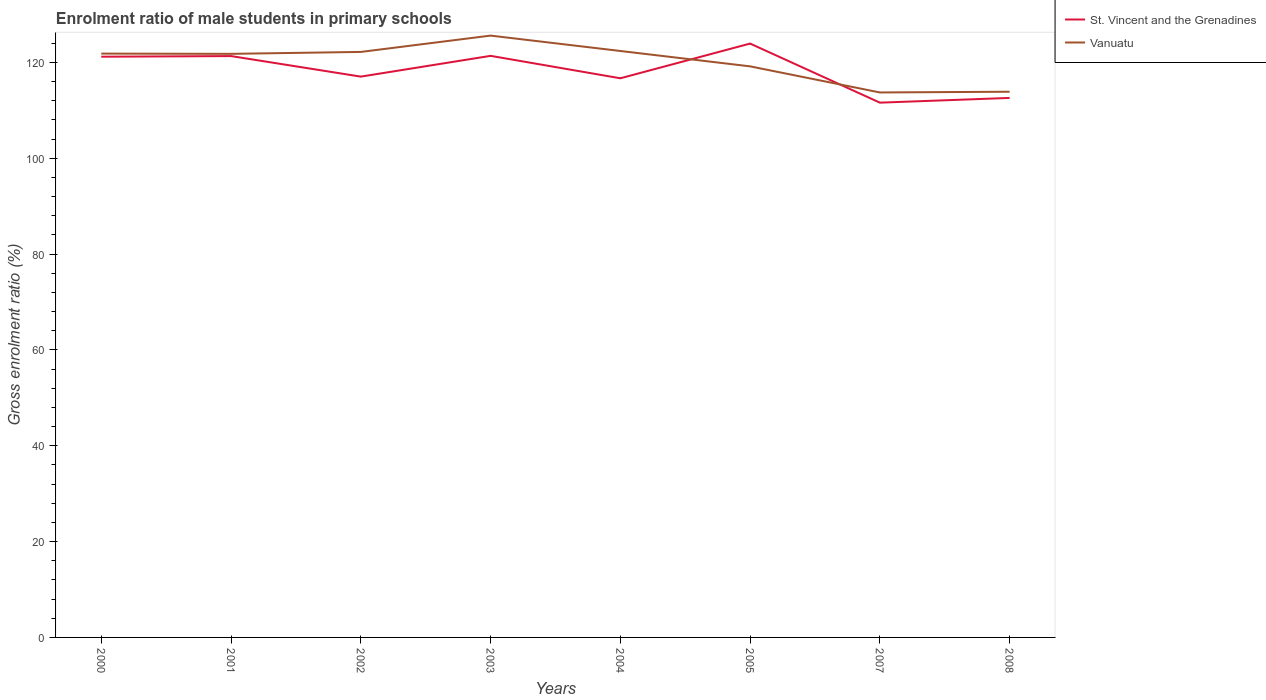Does the line corresponding to Vanuatu intersect with the line corresponding to St. Vincent and the Grenadines?
Your response must be concise. Yes. Across all years, what is the maximum enrolment ratio of male students in primary schools in St. Vincent and the Grenadines?
Keep it short and to the point. 111.59. In which year was the enrolment ratio of male students in primary schools in St. Vincent and the Grenadines maximum?
Make the answer very short. 2007. What is the total enrolment ratio of male students in primary schools in Vanuatu in the graph?
Provide a succinct answer. -0.55. What is the difference between the highest and the second highest enrolment ratio of male students in primary schools in St. Vincent and the Grenadines?
Your answer should be very brief. 12.33. How many years are there in the graph?
Offer a very short reply. 8. Are the values on the major ticks of Y-axis written in scientific E-notation?
Offer a terse response. No. How are the legend labels stacked?
Make the answer very short. Vertical. What is the title of the graph?
Your answer should be compact. Enrolment ratio of male students in primary schools. What is the label or title of the Y-axis?
Your response must be concise. Gross enrolment ratio (%). What is the Gross enrolment ratio (%) of St. Vincent and the Grenadines in 2000?
Make the answer very short. 121.18. What is the Gross enrolment ratio (%) in Vanuatu in 2000?
Your answer should be compact. 121.83. What is the Gross enrolment ratio (%) of St. Vincent and the Grenadines in 2001?
Offer a terse response. 121.31. What is the Gross enrolment ratio (%) in Vanuatu in 2001?
Ensure brevity in your answer.  121.77. What is the Gross enrolment ratio (%) in St. Vincent and the Grenadines in 2002?
Make the answer very short. 117.02. What is the Gross enrolment ratio (%) in Vanuatu in 2002?
Offer a very short reply. 122.17. What is the Gross enrolment ratio (%) of St. Vincent and the Grenadines in 2003?
Keep it short and to the point. 121.36. What is the Gross enrolment ratio (%) of Vanuatu in 2003?
Ensure brevity in your answer.  125.58. What is the Gross enrolment ratio (%) of St. Vincent and the Grenadines in 2004?
Give a very brief answer. 116.68. What is the Gross enrolment ratio (%) of Vanuatu in 2004?
Make the answer very short. 122.37. What is the Gross enrolment ratio (%) of St. Vincent and the Grenadines in 2005?
Offer a terse response. 123.92. What is the Gross enrolment ratio (%) in Vanuatu in 2005?
Your answer should be very brief. 119.16. What is the Gross enrolment ratio (%) of St. Vincent and the Grenadines in 2007?
Give a very brief answer. 111.59. What is the Gross enrolment ratio (%) in Vanuatu in 2007?
Provide a succinct answer. 113.72. What is the Gross enrolment ratio (%) in St. Vincent and the Grenadines in 2008?
Offer a very short reply. 112.58. What is the Gross enrolment ratio (%) in Vanuatu in 2008?
Your answer should be very brief. 113.87. Across all years, what is the maximum Gross enrolment ratio (%) of St. Vincent and the Grenadines?
Make the answer very short. 123.92. Across all years, what is the maximum Gross enrolment ratio (%) in Vanuatu?
Ensure brevity in your answer.  125.58. Across all years, what is the minimum Gross enrolment ratio (%) in St. Vincent and the Grenadines?
Give a very brief answer. 111.59. Across all years, what is the minimum Gross enrolment ratio (%) in Vanuatu?
Offer a terse response. 113.72. What is the total Gross enrolment ratio (%) in St. Vincent and the Grenadines in the graph?
Your answer should be compact. 945.62. What is the total Gross enrolment ratio (%) in Vanuatu in the graph?
Your answer should be compact. 960.47. What is the difference between the Gross enrolment ratio (%) in St. Vincent and the Grenadines in 2000 and that in 2001?
Ensure brevity in your answer.  -0.13. What is the difference between the Gross enrolment ratio (%) of Vanuatu in 2000 and that in 2001?
Offer a terse response. 0.05. What is the difference between the Gross enrolment ratio (%) in St. Vincent and the Grenadines in 2000 and that in 2002?
Provide a short and direct response. 4.16. What is the difference between the Gross enrolment ratio (%) of Vanuatu in 2000 and that in 2002?
Your response must be concise. -0.35. What is the difference between the Gross enrolment ratio (%) of St. Vincent and the Grenadines in 2000 and that in 2003?
Your answer should be very brief. -0.18. What is the difference between the Gross enrolment ratio (%) of Vanuatu in 2000 and that in 2003?
Keep it short and to the point. -3.75. What is the difference between the Gross enrolment ratio (%) of St. Vincent and the Grenadines in 2000 and that in 2004?
Your answer should be very brief. 4.5. What is the difference between the Gross enrolment ratio (%) in Vanuatu in 2000 and that in 2004?
Your response must be concise. -0.55. What is the difference between the Gross enrolment ratio (%) in St. Vincent and the Grenadines in 2000 and that in 2005?
Provide a succinct answer. -2.74. What is the difference between the Gross enrolment ratio (%) of Vanuatu in 2000 and that in 2005?
Offer a very short reply. 2.66. What is the difference between the Gross enrolment ratio (%) of St. Vincent and the Grenadines in 2000 and that in 2007?
Keep it short and to the point. 9.59. What is the difference between the Gross enrolment ratio (%) in Vanuatu in 2000 and that in 2007?
Your answer should be very brief. 8.11. What is the difference between the Gross enrolment ratio (%) in St. Vincent and the Grenadines in 2000 and that in 2008?
Offer a very short reply. 8.6. What is the difference between the Gross enrolment ratio (%) of Vanuatu in 2000 and that in 2008?
Your response must be concise. 7.96. What is the difference between the Gross enrolment ratio (%) of St. Vincent and the Grenadines in 2001 and that in 2002?
Offer a terse response. 4.29. What is the difference between the Gross enrolment ratio (%) of Vanuatu in 2001 and that in 2002?
Offer a terse response. -0.4. What is the difference between the Gross enrolment ratio (%) of St. Vincent and the Grenadines in 2001 and that in 2003?
Offer a very short reply. -0.05. What is the difference between the Gross enrolment ratio (%) in Vanuatu in 2001 and that in 2003?
Make the answer very short. -3.81. What is the difference between the Gross enrolment ratio (%) in St. Vincent and the Grenadines in 2001 and that in 2004?
Offer a terse response. 4.63. What is the difference between the Gross enrolment ratio (%) of Vanuatu in 2001 and that in 2004?
Your response must be concise. -0.6. What is the difference between the Gross enrolment ratio (%) of St. Vincent and the Grenadines in 2001 and that in 2005?
Offer a very short reply. -2.61. What is the difference between the Gross enrolment ratio (%) in Vanuatu in 2001 and that in 2005?
Your response must be concise. 2.61. What is the difference between the Gross enrolment ratio (%) in St. Vincent and the Grenadines in 2001 and that in 2007?
Your answer should be compact. 9.72. What is the difference between the Gross enrolment ratio (%) of Vanuatu in 2001 and that in 2007?
Your answer should be compact. 8.06. What is the difference between the Gross enrolment ratio (%) of St. Vincent and the Grenadines in 2001 and that in 2008?
Offer a very short reply. 8.73. What is the difference between the Gross enrolment ratio (%) in Vanuatu in 2001 and that in 2008?
Offer a very short reply. 7.91. What is the difference between the Gross enrolment ratio (%) of St. Vincent and the Grenadines in 2002 and that in 2003?
Give a very brief answer. -4.33. What is the difference between the Gross enrolment ratio (%) in Vanuatu in 2002 and that in 2003?
Your answer should be very brief. -3.41. What is the difference between the Gross enrolment ratio (%) in St. Vincent and the Grenadines in 2002 and that in 2004?
Your answer should be compact. 0.35. What is the difference between the Gross enrolment ratio (%) in Vanuatu in 2002 and that in 2004?
Keep it short and to the point. -0.2. What is the difference between the Gross enrolment ratio (%) in St. Vincent and the Grenadines in 2002 and that in 2005?
Offer a very short reply. -6.9. What is the difference between the Gross enrolment ratio (%) in Vanuatu in 2002 and that in 2005?
Make the answer very short. 3.01. What is the difference between the Gross enrolment ratio (%) in St. Vincent and the Grenadines in 2002 and that in 2007?
Provide a short and direct response. 5.43. What is the difference between the Gross enrolment ratio (%) of Vanuatu in 2002 and that in 2007?
Offer a very short reply. 8.46. What is the difference between the Gross enrolment ratio (%) of St. Vincent and the Grenadines in 2002 and that in 2008?
Your answer should be very brief. 4.44. What is the difference between the Gross enrolment ratio (%) of Vanuatu in 2002 and that in 2008?
Make the answer very short. 8.31. What is the difference between the Gross enrolment ratio (%) in St. Vincent and the Grenadines in 2003 and that in 2004?
Make the answer very short. 4.68. What is the difference between the Gross enrolment ratio (%) in Vanuatu in 2003 and that in 2004?
Offer a terse response. 3.21. What is the difference between the Gross enrolment ratio (%) of St. Vincent and the Grenadines in 2003 and that in 2005?
Provide a succinct answer. -2.56. What is the difference between the Gross enrolment ratio (%) in Vanuatu in 2003 and that in 2005?
Ensure brevity in your answer.  6.42. What is the difference between the Gross enrolment ratio (%) of St. Vincent and the Grenadines in 2003 and that in 2007?
Your answer should be compact. 9.77. What is the difference between the Gross enrolment ratio (%) of Vanuatu in 2003 and that in 2007?
Make the answer very short. 11.86. What is the difference between the Gross enrolment ratio (%) of St. Vincent and the Grenadines in 2003 and that in 2008?
Your response must be concise. 8.78. What is the difference between the Gross enrolment ratio (%) in Vanuatu in 2003 and that in 2008?
Keep it short and to the point. 11.71. What is the difference between the Gross enrolment ratio (%) of St. Vincent and the Grenadines in 2004 and that in 2005?
Make the answer very short. -7.24. What is the difference between the Gross enrolment ratio (%) of Vanuatu in 2004 and that in 2005?
Ensure brevity in your answer.  3.21. What is the difference between the Gross enrolment ratio (%) of St. Vincent and the Grenadines in 2004 and that in 2007?
Provide a succinct answer. 5.09. What is the difference between the Gross enrolment ratio (%) of Vanuatu in 2004 and that in 2007?
Ensure brevity in your answer.  8.65. What is the difference between the Gross enrolment ratio (%) of St. Vincent and the Grenadines in 2004 and that in 2008?
Give a very brief answer. 4.1. What is the difference between the Gross enrolment ratio (%) in Vanuatu in 2004 and that in 2008?
Your response must be concise. 8.5. What is the difference between the Gross enrolment ratio (%) of St. Vincent and the Grenadines in 2005 and that in 2007?
Offer a terse response. 12.33. What is the difference between the Gross enrolment ratio (%) in Vanuatu in 2005 and that in 2007?
Make the answer very short. 5.45. What is the difference between the Gross enrolment ratio (%) of St. Vincent and the Grenadines in 2005 and that in 2008?
Make the answer very short. 11.34. What is the difference between the Gross enrolment ratio (%) in Vanuatu in 2005 and that in 2008?
Keep it short and to the point. 5.3. What is the difference between the Gross enrolment ratio (%) of St. Vincent and the Grenadines in 2007 and that in 2008?
Give a very brief answer. -0.99. What is the difference between the Gross enrolment ratio (%) in Vanuatu in 2007 and that in 2008?
Your answer should be compact. -0.15. What is the difference between the Gross enrolment ratio (%) in St. Vincent and the Grenadines in 2000 and the Gross enrolment ratio (%) in Vanuatu in 2001?
Your answer should be very brief. -0.6. What is the difference between the Gross enrolment ratio (%) in St. Vincent and the Grenadines in 2000 and the Gross enrolment ratio (%) in Vanuatu in 2002?
Your response must be concise. -1. What is the difference between the Gross enrolment ratio (%) in St. Vincent and the Grenadines in 2000 and the Gross enrolment ratio (%) in Vanuatu in 2003?
Your answer should be very brief. -4.4. What is the difference between the Gross enrolment ratio (%) of St. Vincent and the Grenadines in 2000 and the Gross enrolment ratio (%) of Vanuatu in 2004?
Give a very brief answer. -1.19. What is the difference between the Gross enrolment ratio (%) in St. Vincent and the Grenadines in 2000 and the Gross enrolment ratio (%) in Vanuatu in 2005?
Ensure brevity in your answer.  2.02. What is the difference between the Gross enrolment ratio (%) in St. Vincent and the Grenadines in 2000 and the Gross enrolment ratio (%) in Vanuatu in 2007?
Keep it short and to the point. 7.46. What is the difference between the Gross enrolment ratio (%) of St. Vincent and the Grenadines in 2000 and the Gross enrolment ratio (%) of Vanuatu in 2008?
Keep it short and to the point. 7.31. What is the difference between the Gross enrolment ratio (%) in St. Vincent and the Grenadines in 2001 and the Gross enrolment ratio (%) in Vanuatu in 2002?
Offer a very short reply. -0.87. What is the difference between the Gross enrolment ratio (%) of St. Vincent and the Grenadines in 2001 and the Gross enrolment ratio (%) of Vanuatu in 2003?
Your answer should be very brief. -4.27. What is the difference between the Gross enrolment ratio (%) of St. Vincent and the Grenadines in 2001 and the Gross enrolment ratio (%) of Vanuatu in 2004?
Keep it short and to the point. -1.06. What is the difference between the Gross enrolment ratio (%) of St. Vincent and the Grenadines in 2001 and the Gross enrolment ratio (%) of Vanuatu in 2005?
Offer a very short reply. 2.15. What is the difference between the Gross enrolment ratio (%) in St. Vincent and the Grenadines in 2001 and the Gross enrolment ratio (%) in Vanuatu in 2007?
Your response must be concise. 7.59. What is the difference between the Gross enrolment ratio (%) of St. Vincent and the Grenadines in 2001 and the Gross enrolment ratio (%) of Vanuatu in 2008?
Give a very brief answer. 7.44. What is the difference between the Gross enrolment ratio (%) in St. Vincent and the Grenadines in 2002 and the Gross enrolment ratio (%) in Vanuatu in 2003?
Your answer should be compact. -8.56. What is the difference between the Gross enrolment ratio (%) in St. Vincent and the Grenadines in 2002 and the Gross enrolment ratio (%) in Vanuatu in 2004?
Your response must be concise. -5.35. What is the difference between the Gross enrolment ratio (%) of St. Vincent and the Grenadines in 2002 and the Gross enrolment ratio (%) of Vanuatu in 2005?
Keep it short and to the point. -2.14. What is the difference between the Gross enrolment ratio (%) of St. Vincent and the Grenadines in 2002 and the Gross enrolment ratio (%) of Vanuatu in 2007?
Your answer should be very brief. 3.3. What is the difference between the Gross enrolment ratio (%) in St. Vincent and the Grenadines in 2002 and the Gross enrolment ratio (%) in Vanuatu in 2008?
Make the answer very short. 3.15. What is the difference between the Gross enrolment ratio (%) in St. Vincent and the Grenadines in 2003 and the Gross enrolment ratio (%) in Vanuatu in 2004?
Offer a very short reply. -1.02. What is the difference between the Gross enrolment ratio (%) in St. Vincent and the Grenadines in 2003 and the Gross enrolment ratio (%) in Vanuatu in 2005?
Make the answer very short. 2.19. What is the difference between the Gross enrolment ratio (%) in St. Vincent and the Grenadines in 2003 and the Gross enrolment ratio (%) in Vanuatu in 2007?
Keep it short and to the point. 7.64. What is the difference between the Gross enrolment ratio (%) of St. Vincent and the Grenadines in 2003 and the Gross enrolment ratio (%) of Vanuatu in 2008?
Your answer should be very brief. 7.49. What is the difference between the Gross enrolment ratio (%) of St. Vincent and the Grenadines in 2004 and the Gross enrolment ratio (%) of Vanuatu in 2005?
Keep it short and to the point. -2.49. What is the difference between the Gross enrolment ratio (%) in St. Vincent and the Grenadines in 2004 and the Gross enrolment ratio (%) in Vanuatu in 2007?
Offer a terse response. 2.96. What is the difference between the Gross enrolment ratio (%) in St. Vincent and the Grenadines in 2004 and the Gross enrolment ratio (%) in Vanuatu in 2008?
Your answer should be compact. 2.81. What is the difference between the Gross enrolment ratio (%) of St. Vincent and the Grenadines in 2005 and the Gross enrolment ratio (%) of Vanuatu in 2007?
Provide a short and direct response. 10.2. What is the difference between the Gross enrolment ratio (%) in St. Vincent and the Grenadines in 2005 and the Gross enrolment ratio (%) in Vanuatu in 2008?
Keep it short and to the point. 10.05. What is the difference between the Gross enrolment ratio (%) of St. Vincent and the Grenadines in 2007 and the Gross enrolment ratio (%) of Vanuatu in 2008?
Offer a terse response. -2.28. What is the average Gross enrolment ratio (%) in St. Vincent and the Grenadines per year?
Offer a very short reply. 118.2. What is the average Gross enrolment ratio (%) of Vanuatu per year?
Give a very brief answer. 120.06. In the year 2000, what is the difference between the Gross enrolment ratio (%) in St. Vincent and the Grenadines and Gross enrolment ratio (%) in Vanuatu?
Offer a very short reply. -0.65. In the year 2001, what is the difference between the Gross enrolment ratio (%) in St. Vincent and the Grenadines and Gross enrolment ratio (%) in Vanuatu?
Offer a terse response. -0.47. In the year 2002, what is the difference between the Gross enrolment ratio (%) in St. Vincent and the Grenadines and Gross enrolment ratio (%) in Vanuatu?
Your answer should be compact. -5.15. In the year 2003, what is the difference between the Gross enrolment ratio (%) in St. Vincent and the Grenadines and Gross enrolment ratio (%) in Vanuatu?
Your answer should be very brief. -4.22. In the year 2004, what is the difference between the Gross enrolment ratio (%) in St. Vincent and the Grenadines and Gross enrolment ratio (%) in Vanuatu?
Your answer should be very brief. -5.7. In the year 2005, what is the difference between the Gross enrolment ratio (%) in St. Vincent and the Grenadines and Gross enrolment ratio (%) in Vanuatu?
Your answer should be very brief. 4.76. In the year 2007, what is the difference between the Gross enrolment ratio (%) in St. Vincent and the Grenadines and Gross enrolment ratio (%) in Vanuatu?
Give a very brief answer. -2.13. In the year 2008, what is the difference between the Gross enrolment ratio (%) in St. Vincent and the Grenadines and Gross enrolment ratio (%) in Vanuatu?
Offer a very short reply. -1.29. What is the ratio of the Gross enrolment ratio (%) of St. Vincent and the Grenadines in 2000 to that in 2001?
Keep it short and to the point. 1. What is the ratio of the Gross enrolment ratio (%) in St. Vincent and the Grenadines in 2000 to that in 2002?
Your answer should be compact. 1.04. What is the ratio of the Gross enrolment ratio (%) in Vanuatu in 2000 to that in 2002?
Your answer should be very brief. 1. What is the ratio of the Gross enrolment ratio (%) of St. Vincent and the Grenadines in 2000 to that in 2003?
Your response must be concise. 1. What is the ratio of the Gross enrolment ratio (%) in Vanuatu in 2000 to that in 2003?
Keep it short and to the point. 0.97. What is the ratio of the Gross enrolment ratio (%) in St. Vincent and the Grenadines in 2000 to that in 2004?
Offer a very short reply. 1.04. What is the ratio of the Gross enrolment ratio (%) in St. Vincent and the Grenadines in 2000 to that in 2005?
Offer a very short reply. 0.98. What is the ratio of the Gross enrolment ratio (%) of Vanuatu in 2000 to that in 2005?
Provide a succinct answer. 1.02. What is the ratio of the Gross enrolment ratio (%) of St. Vincent and the Grenadines in 2000 to that in 2007?
Keep it short and to the point. 1.09. What is the ratio of the Gross enrolment ratio (%) of Vanuatu in 2000 to that in 2007?
Provide a short and direct response. 1.07. What is the ratio of the Gross enrolment ratio (%) in St. Vincent and the Grenadines in 2000 to that in 2008?
Offer a terse response. 1.08. What is the ratio of the Gross enrolment ratio (%) in Vanuatu in 2000 to that in 2008?
Provide a short and direct response. 1.07. What is the ratio of the Gross enrolment ratio (%) in St. Vincent and the Grenadines in 2001 to that in 2002?
Ensure brevity in your answer.  1.04. What is the ratio of the Gross enrolment ratio (%) in Vanuatu in 2001 to that in 2003?
Ensure brevity in your answer.  0.97. What is the ratio of the Gross enrolment ratio (%) of St. Vincent and the Grenadines in 2001 to that in 2004?
Offer a very short reply. 1.04. What is the ratio of the Gross enrolment ratio (%) of Vanuatu in 2001 to that in 2004?
Offer a very short reply. 1. What is the ratio of the Gross enrolment ratio (%) in St. Vincent and the Grenadines in 2001 to that in 2005?
Ensure brevity in your answer.  0.98. What is the ratio of the Gross enrolment ratio (%) in Vanuatu in 2001 to that in 2005?
Give a very brief answer. 1.02. What is the ratio of the Gross enrolment ratio (%) of St. Vincent and the Grenadines in 2001 to that in 2007?
Offer a terse response. 1.09. What is the ratio of the Gross enrolment ratio (%) of Vanuatu in 2001 to that in 2007?
Ensure brevity in your answer.  1.07. What is the ratio of the Gross enrolment ratio (%) of St. Vincent and the Grenadines in 2001 to that in 2008?
Provide a succinct answer. 1.08. What is the ratio of the Gross enrolment ratio (%) of Vanuatu in 2001 to that in 2008?
Provide a short and direct response. 1.07. What is the ratio of the Gross enrolment ratio (%) of St. Vincent and the Grenadines in 2002 to that in 2003?
Keep it short and to the point. 0.96. What is the ratio of the Gross enrolment ratio (%) in Vanuatu in 2002 to that in 2003?
Offer a very short reply. 0.97. What is the ratio of the Gross enrolment ratio (%) of St. Vincent and the Grenadines in 2002 to that in 2005?
Offer a very short reply. 0.94. What is the ratio of the Gross enrolment ratio (%) of Vanuatu in 2002 to that in 2005?
Your answer should be compact. 1.03. What is the ratio of the Gross enrolment ratio (%) of St. Vincent and the Grenadines in 2002 to that in 2007?
Ensure brevity in your answer.  1.05. What is the ratio of the Gross enrolment ratio (%) in Vanuatu in 2002 to that in 2007?
Give a very brief answer. 1.07. What is the ratio of the Gross enrolment ratio (%) in St. Vincent and the Grenadines in 2002 to that in 2008?
Make the answer very short. 1.04. What is the ratio of the Gross enrolment ratio (%) in Vanuatu in 2002 to that in 2008?
Your answer should be very brief. 1.07. What is the ratio of the Gross enrolment ratio (%) of St. Vincent and the Grenadines in 2003 to that in 2004?
Your answer should be very brief. 1.04. What is the ratio of the Gross enrolment ratio (%) of Vanuatu in 2003 to that in 2004?
Your response must be concise. 1.03. What is the ratio of the Gross enrolment ratio (%) in St. Vincent and the Grenadines in 2003 to that in 2005?
Provide a short and direct response. 0.98. What is the ratio of the Gross enrolment ratio (%) of Vanuatu in 2003 to that in 2005?
Provide a short and direct response. 1.05. What is the ratio of the Gross enrolment ratio (%) of St. Vincent and the Grenadines in 2003 to that in 2007?
Make the answer very short. 1.09. What is the ratio of the Gross enrolment ratio (%) in Vanuatu in 2003 to that in 2007?
Make the answer very short. 1.1. What is the ratio of the Gross enrolment ratio (%) of St. Vincent and the Grenadines in 2003 to that in 2008?
Make the answer very short. 1.08. What is the ratio of the Gross enrolment ratio (%) of Vanuatu in 2003 to that in 2008?
Provide a short and direct response. 1.1. What is the ratio of the Gross enrolment ratio (%) of St. Vincent and the Grenadines in 2004 to that in 2005?
Offer a very short reply. 0.94. What is the ratio of the Gross enrolment ratio (%) of Vanuatu in 2004 to that in 2005?
Give a very brief answer. 1.03. What is the ratio of the Gross enrolment ratio (%) in St. Vincent and the Grenadines in 2004 to that in 2007?
Make the answer very short. 1.05. What is the ratio of the Gross enrolment ratio (%) in Vanuatu in 2004 to that in 2007?
Your answer should be compact. 1.08. What is the ratio of the Gross enrolment ratio (%) of St. Vincent and the Grenadines in 2004 to that in 2008?
Give a very brief answer. 1.04. What is the ratio of the Gross enrolment ratio (%) of Vanuatu in 2004 to that in 2008?
Give a very brief answer. 1.07. What is the ratio of the Gross enrolment ratio (%) in St. Vincent and the Grenadines in 2005 to that in 2007?
Your answer should be compact. 1.11. What is the ratio of the Gross enrolment ratio (%) of Vanuatu in 2005 to that in 2007?
Provide a short and direct response. 1.05. What is the ratio of the Gross enrolment ratio (%) of St. Vincent and the Grenadines in 2005 to that in 2008?
Your answer should be very brief. 1.1. What is the ratio of the Gross enrolment ratio (%) of Vanuatu in 2005 to that in 2008?
Your answer should be compact. 1.05. What is the ratio of the Gross enrolment ratio (%) of St. Vincent and the Grenadines in 2007 to that in 2008?
Provide a succinct answer. 0.99. What is the difference between the highest and the second highest Gross enrolment ratio (%) of St. Vincent and the Grenadines?
Offer a very short reply. 2.56. What is the difference between the highest and the second highest Gross enrolment ratio (%) of Vanuatu?
Offer a very short reply. 3.21. What is the difference between the highest and the lowest Gross enrolment ratio (%) in St. Vincent and the Grenadines?
Offer a very short reply. 12.33. What is the difference between the highest and the lowest Gross enrolment ratio (%) in Vanuatu?
Provide a succinct answer. 11.86. 